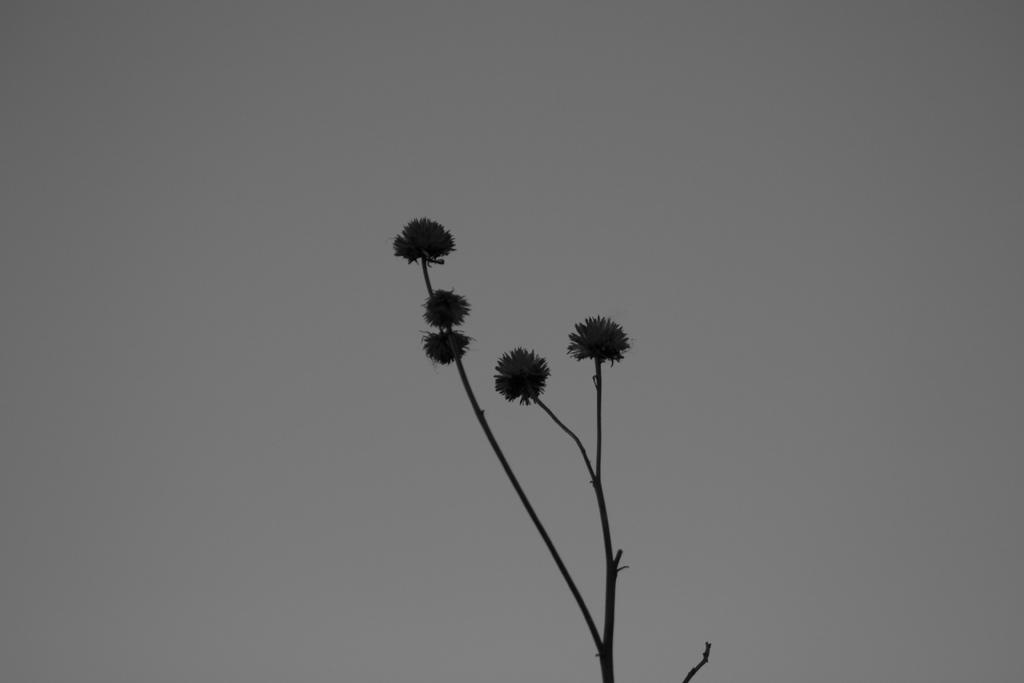What is the main object in the image? There is a branch in the image. What can be seen in the background of the image? The background of the image is gray. How many stamps are on the branch in the image? There are no stamps present in the image; it only features a branch. What type of soda can be seen being poured from the branch in the image? There is no soda present in the image; it only features a branch. 